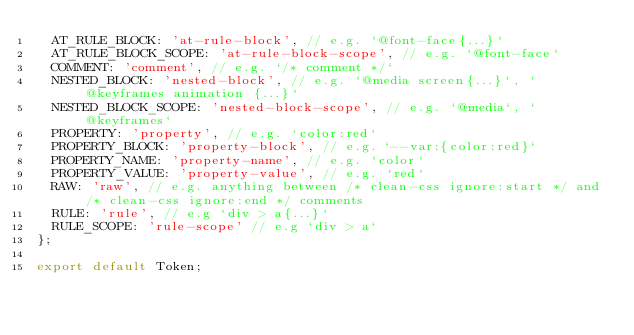<code> <loc_0><loc_0><loc_500><loc_500><_JavaScript_>  AT_RULE_BLOCK: 'at-rule-block', // e.g. `@font-face{...}`
  AT_RULE_BLOCK_SCOPE: 'at-rule-block-scope', // e.g. `@font-face`
  COMMENT: 'comment', // e.g. `/* comment */`
  NESTED_BLOCK: 'nested-block', // e.g. `@media screen{...}`, `@keyframes animation {...}`
  NESTED_BLOCK_SCOPE: 'nested-block-scope', // e.g. `@media`, `@keyframes`
  PROPERTY: 'property', // e.g. `color:red`
  PROPERTY_BLOCK: 'property-block', // e.g. `--var:{color:red}`
  PROPERTY_NAME: 'property-name', // e.g. `color`
  PROPERTY_VALUE: 'property-value', // e.g. `red`
  RAW: 'raw', // e.g. anything between /* clean-css ignore:start */ and /* clean-css ignore:end */ comments
  RULE: 'rule', // e.g `div > a{...}`
  RULE_SCOPE: 'rule-scope' // e.g `div > a`
};

export default Token;
</code> 